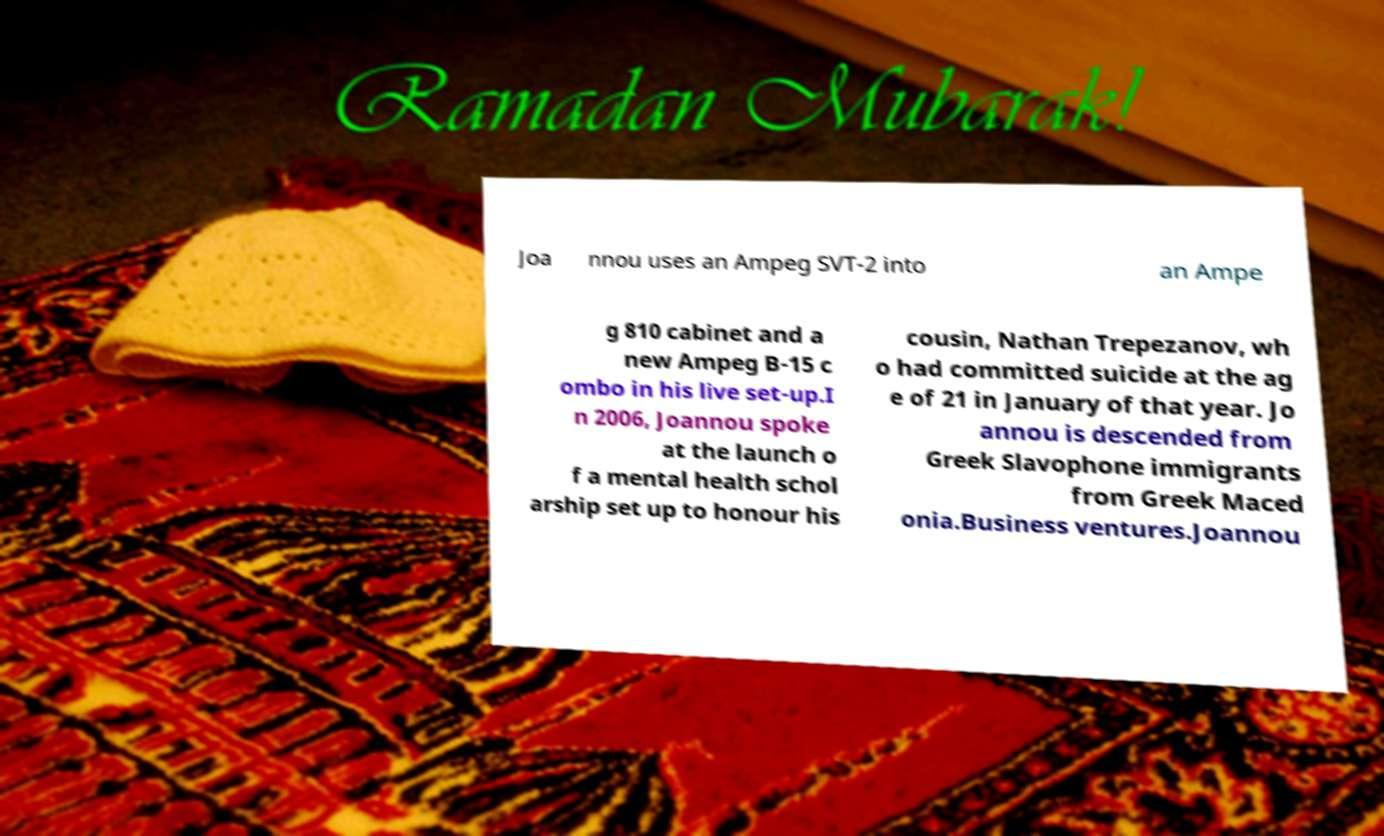I need the written content from this picture converted into text. Can you do that? Joa nnou uses an Ampeg SVT-2 into an Ampe g 810 cabinet and a new Ampeg B-15 c ombo in his live set-up.I n 2006, Joannou spoke at the launch o f a mental health schol arship set up to honour his cousin, Nathan Trepezanov, wh o had committed suicide at the ag e of 21 in January of that year. Jo annou is descended from Greek Slavophone immigrants from Greek Maced onia.Business ventures.Joannou 